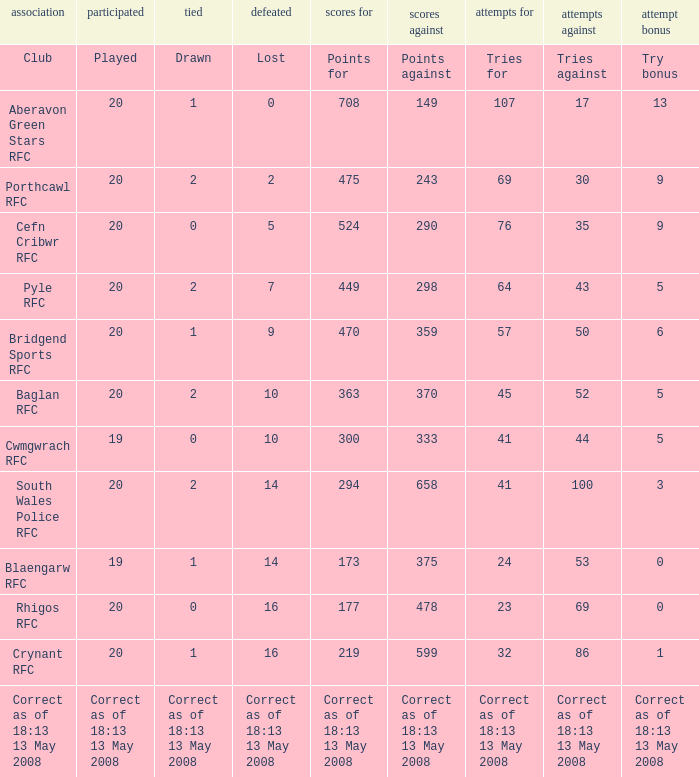What is the points number when 20 shows for played, and lost is 0? 708.0. Can you parse all the data within this table? {'header': ['association', 'participated', 'tied', 'defeated', 'scores for', 'scores against', 'attempts for', 'attempts against', 'attempt bonus'], 'rows': [['Club', 'Played', 'Drawn', 'Lost', 'Points for', 'Points against', 'Tries for', 'Tries against', 'Try bonus'], ['Aberavon Green Stars RFC', '20', '1', '0', '708', '149', '107', '17', '13'], ['Porthcawl RFC', '20', '2', '2', '475', '243', '69', '30', '9'], ['Cefn Cribwr RFC', '20', '0', '5', '524', '290', '76', '35', '9'], ['Pyle RFC', '20', '2', '7', '449', '298', '64', '43', '5'], ['Bridgend Sports RFC', '20', '1', '9', '470', '359', '57', '50', '6'], ['Baglan RFC', '20', '2', '10', '363', '370', '45', '52', '5'], ['Cwmgwrach RFC', '19', '0', '10', '300', '333', '41', '44', '5'], ['South Wales Police RFC', '20', '2', '14', '294', '658', '41', '100', '3'], ['Blaengarw RFC', '19', '1', '14', '173', '375', '24', '53', '0'], ['Rhigos RFC', '20', '0', '16', '177', '478', '23', '69', '0'], ['Crynant RFC', '20', '1', '16', '219', '599', '32', '86', '1'], ['Correct as of 18:13 13 May 2008', 'Correct as of 18:13 13 May 2008', 'Correct as of 18:13 13 May 2008', 'Correct as of 18:13 13 May 2008', 'Correct as of 18:13 13 May 2008', 'Correct as of 18:13 13 May 2008', 'Correct as of 18:13 13 May 2008', 'Correct as of 18:13 13 May 2008', 'Correct as of 18:13 13 May 2008']]} 